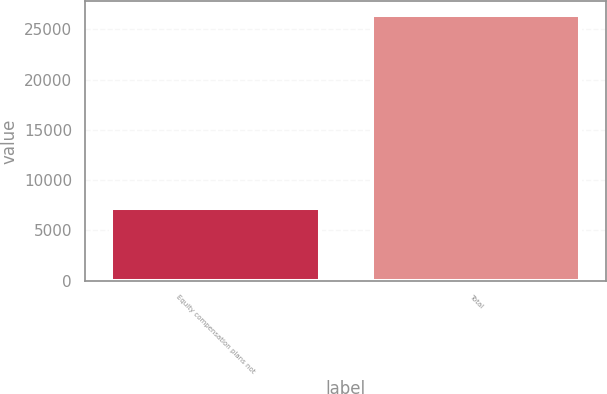Convert chart to OTSL. <chart><loc_0><loc_0><loc_500><loc_500><bar_chart><fcel>Equity compensation plans not<fcel>Total<nl><fcel>7199<fcel>26468<nl></chart> 